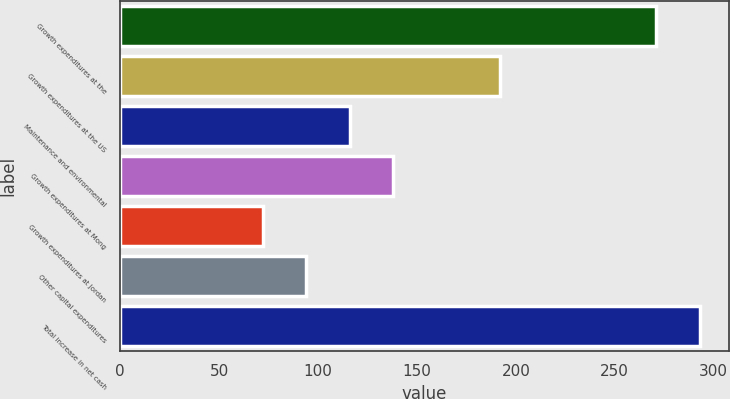<chart> <loc_0><loc_0><loc_500><loc_500><bar_chart><fcel>Growth expenditures at the<fcel>Growth expenditures at the US<fcel>Maintenance and environmental<fcel>Growth expenditures at Mong<fcel>Growth expenditures at Jordan<fcel>Other capital expenditures<fcel>Total increase in net cash<nl><fcel>271<fcel>192<fcel>116<fcel>138<fcel>72<fcel>94<fcel>293<nl></chart> 